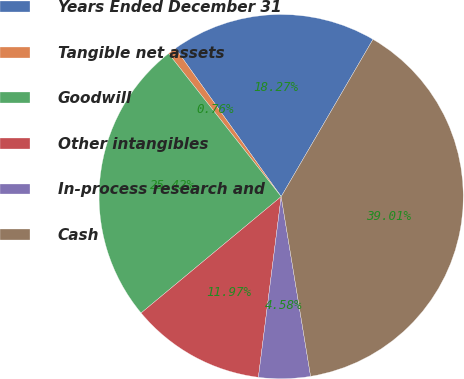Convert chart. <chart><loc_0><loc_0><loc_500><loc_500><pie_chart><fcel>Years Ended December 31<fcel>Tangible net assets<fcel>Goodwill<fcel>Other intangibles<fcel>In-process research and<fcel>Cash<nl><fcel>18.27%<fcel>0.76%<fcel>25.42%<fcel>11.97%<fcel>4.58%<fcel>39.01%<nl></chart> 